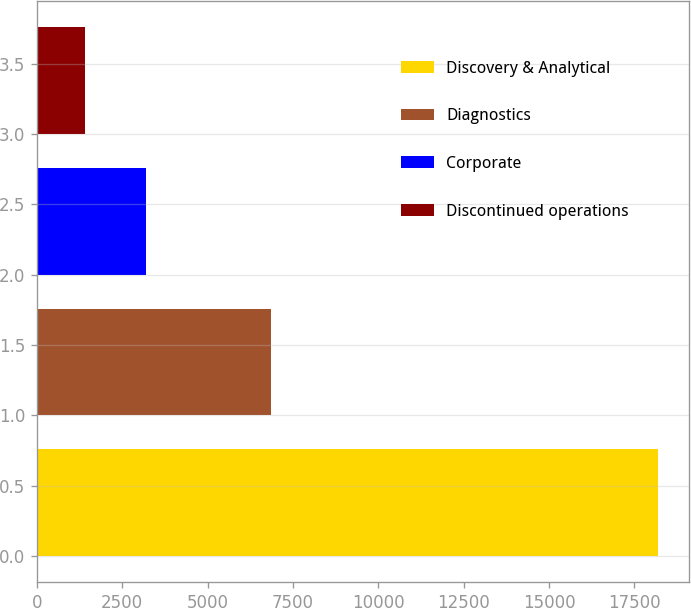<chart> <loc_0><loc_0><loc_500><loc_500><bar_chart><fcel>Discovery & Analytical<fcel>Diagnostics<fcel>Corporate<fcel>Discontinued operations<nl><fcel>18175<fcel>6854<fcel>3189<fcel>1414<nl></chart> 